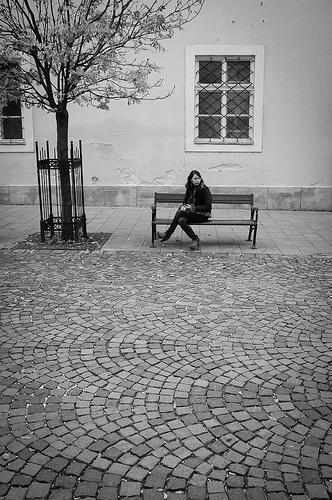How many windows can be seen?
Give a very brief answer. 2. 